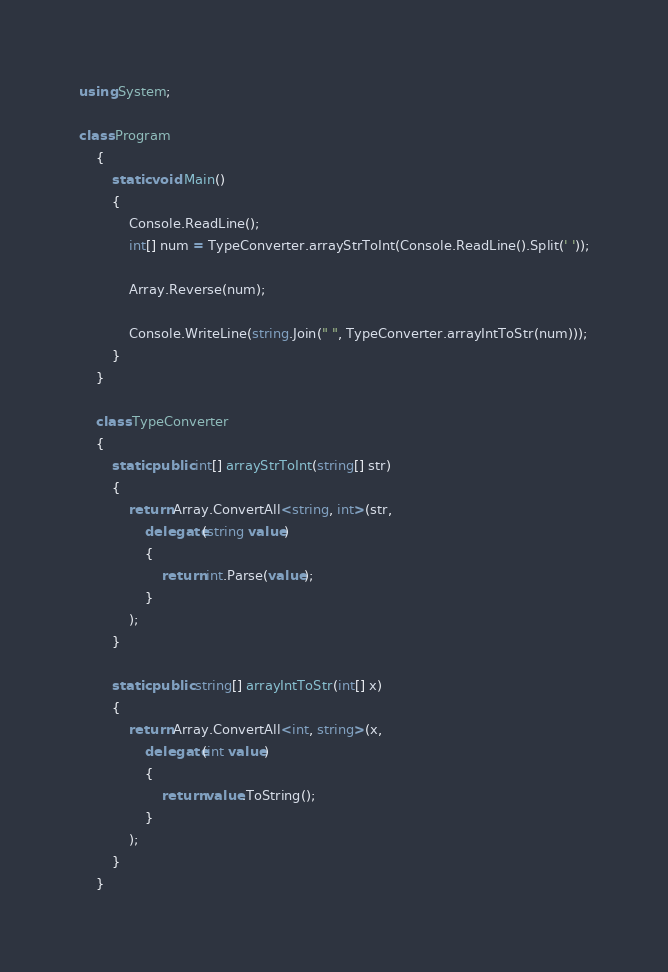Convert code to text. <code><loc_0><loc_0><loc_500><loc_500><_C#_>using System;

class Program
    {
        static void Main()
        {
            Console.ReadLine();
            int[] num = TypeConverter.arrayStrToInt(Console.ReadLine().Split(' '));

            Array.Reverse(num);

            Console.WriteLine(string.Join(" ", TypeConverter.arrayIntToStr(num)));
        }
    }

    class TypeConverter
    {
        static public int[] arrayStrToInt(string[] str)
        {
            return Array.ConvertAll<string, int>(str,
                delegate(string value)
                {
                    return int.Parse(value);
                }
            );
        }

        static public string[] arrayIntToStr(int[] x)
        {
            return Array.ConvertAll<int, string>(x,
                delegate(int value)
                {
                    return value.ToString();
                }
            );
        }
    }</code> 